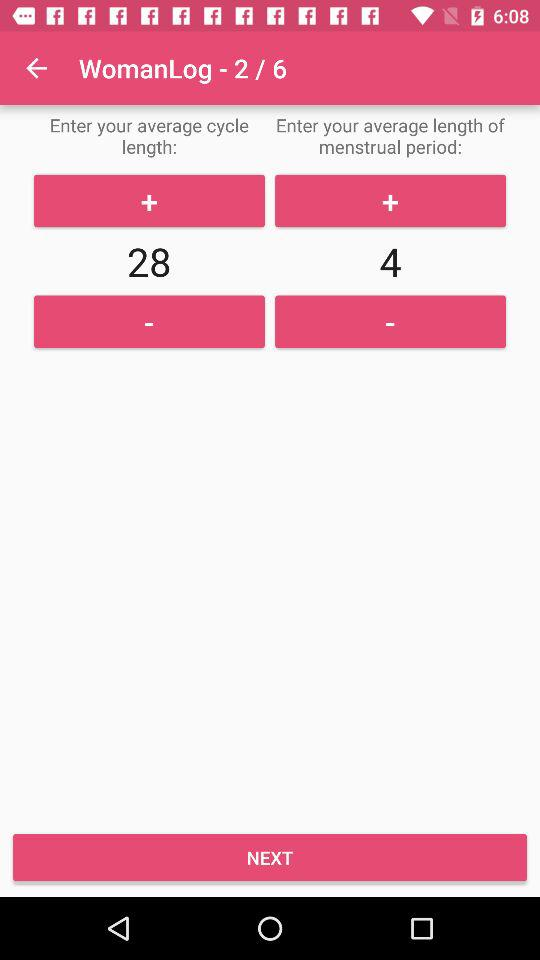How many days long is the average cycle length?
Answer the question using a single word or phrase. 28 